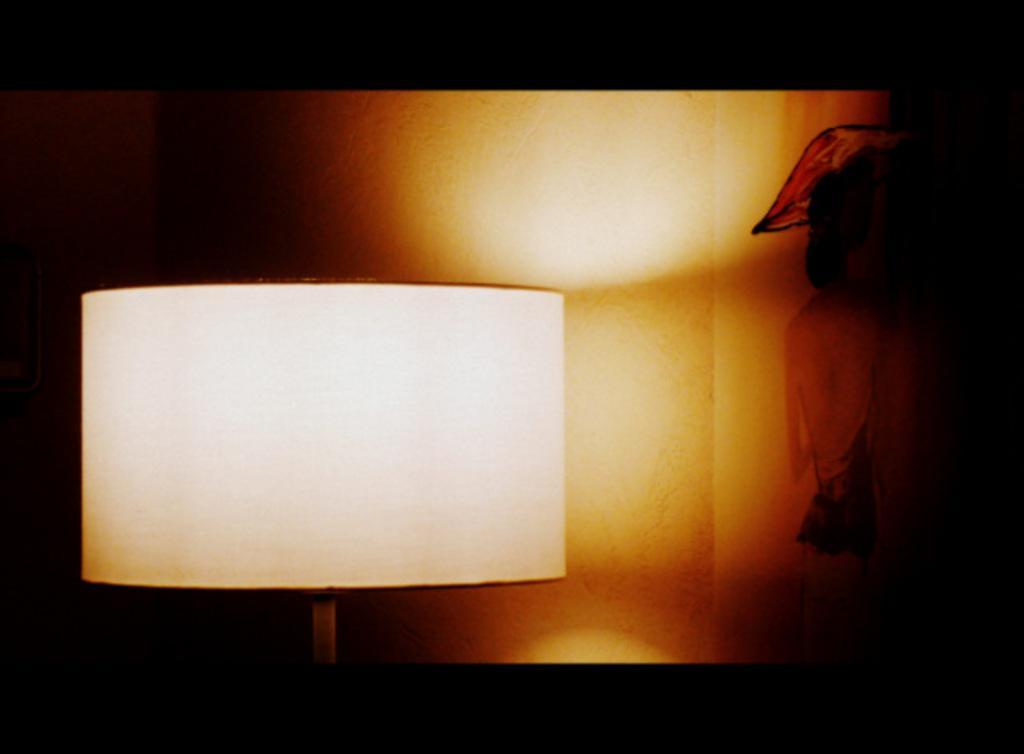Can you describe this image briefly? In this image I can see the lamp. Background is in black, brown and white color. 